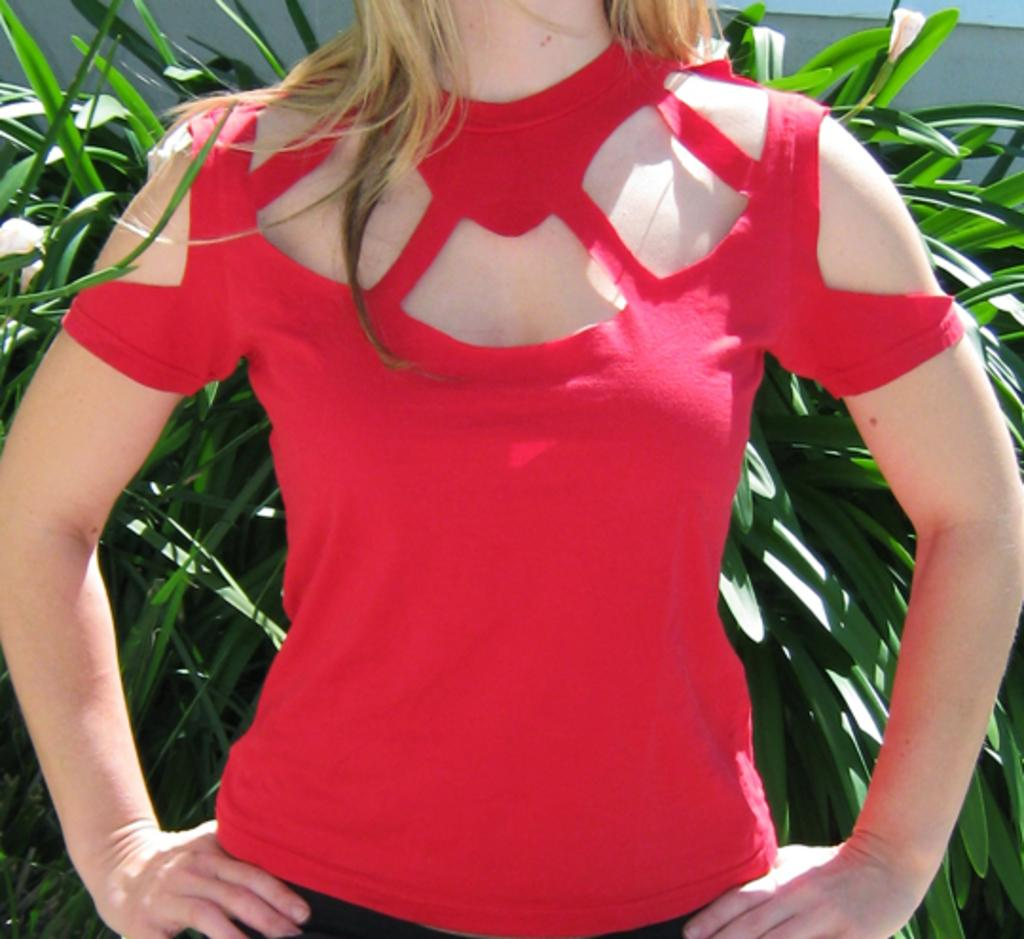Who is the main subject in the image? There is a woman in the image. What is the woman wearing? The woman is wearing a red top. What can be seen in the background of the image? There are plants and a wall visible in the background of the image. What detail can be seen on the woman's partner's shirt in the image? There is no partner present in the image, and therefore no detail on their shirt can be observed. 